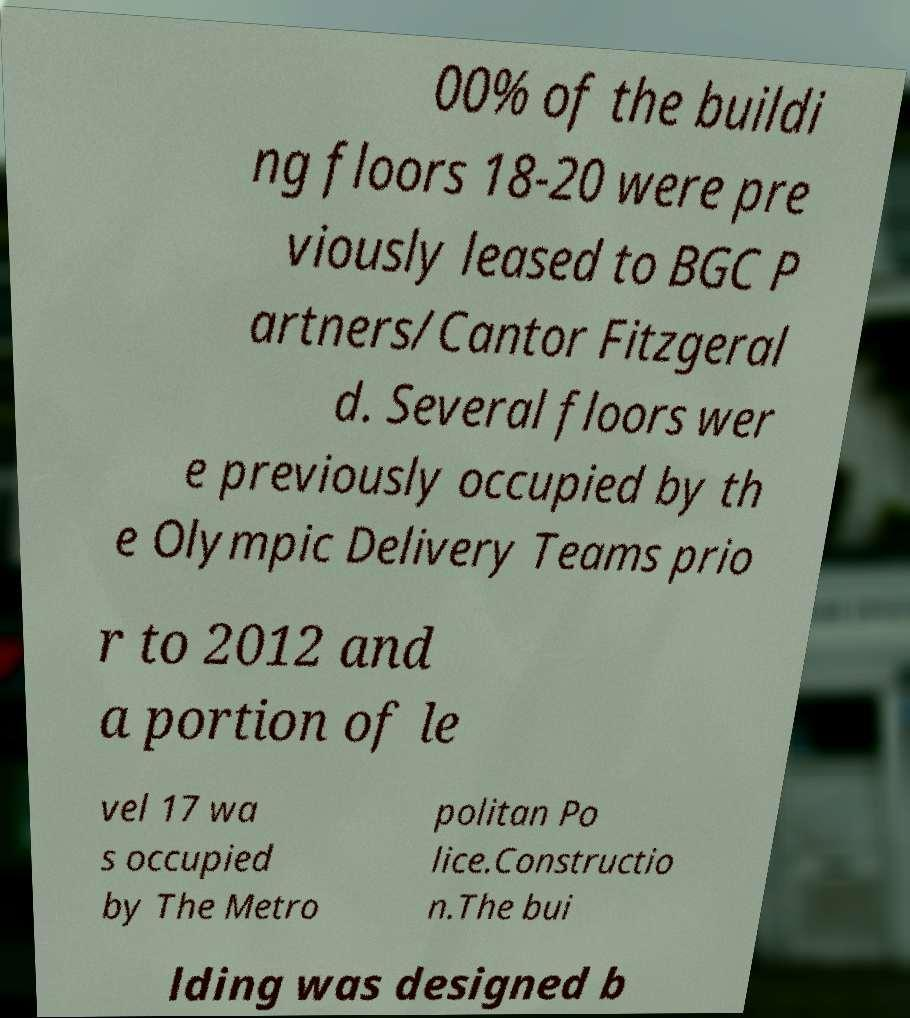Can you accurately transcribe the text from the provided image for me? 00% of the buildi ng floors 18-20 were pre viously leased to BGC P artners/Cantor Fitzgeral d. Several floors wer e previously occupied by th e Olympic Delivery Teams prio r to 2012 and a portion of le vel 17 wa s occupied by The Metro politan Po lice.Constructio n.The bui lding was designed b 